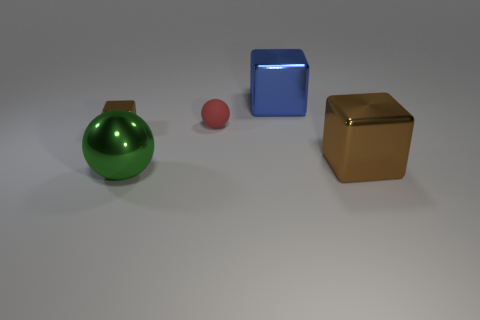Add 1 large brown objects. How many objects exist? 6 Subtract all spheres. How many objects are left? 3 Subtract all metal things. Subtract all tiny brown things. How many objects are left? 0 Add 4 green metallic objects. How many green metallic objects are left? 5 Add 2 large metal blocks. How many large metal blocks exist? 4 Subtract 0 purple balls. How many objects are left? 5 